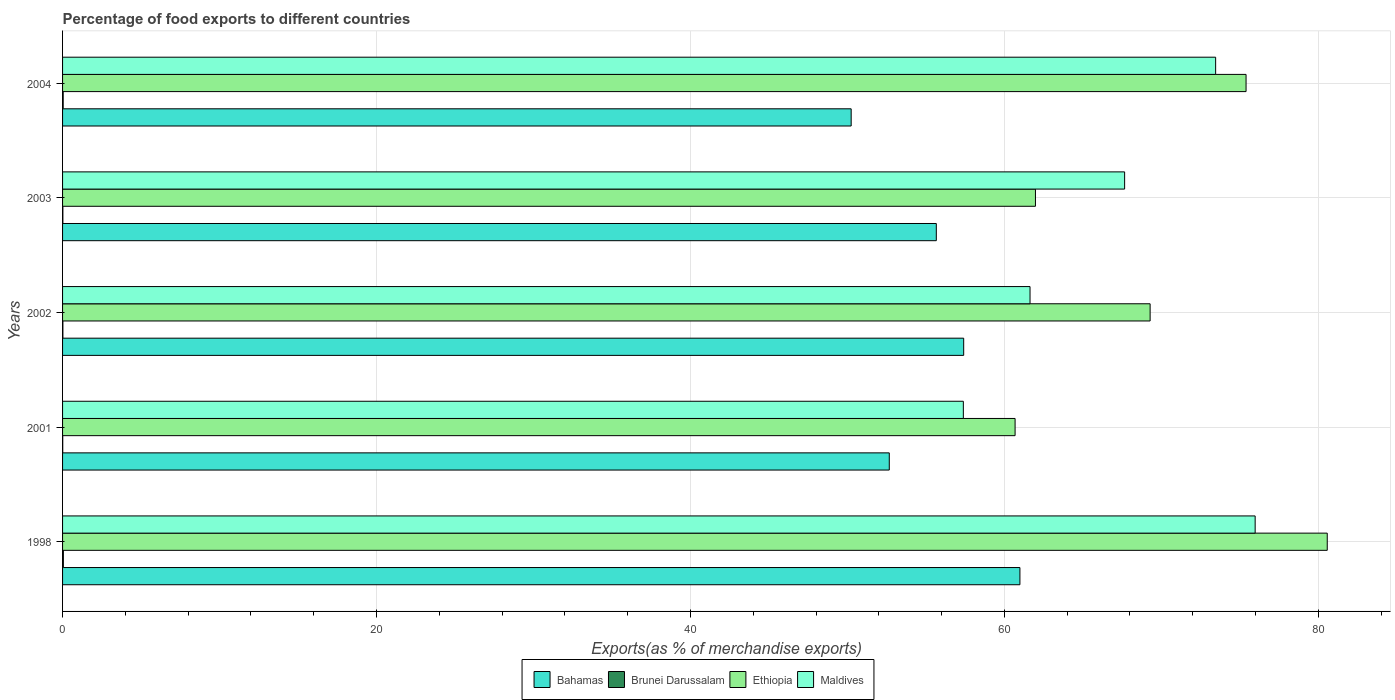How many groups of bars are there?
Make the answer very short. 5. Are the number of bars per tick equal to the number of legend labels?
Your answer should be compact. Yes. How many bars are there on the 3rd tick from the top?
Ensure brevity in your answer.  4. What is the percentage of exports to different countries in Bahamas in 2004?
Your response must be concise. 50.24. Across all years, what is the maximum percentage of exports to different countries in Maldives?
Provide a succinct answer. 75.97. Across all years, what is the minimum percentage of exports to different countries in Bahamas?
Ensure brevity in your answer.  50.24. In which year was the percentage of exports to different countries in Maldives maximum?
Give a very brief answer. 1998. In which year was the percentage of exports to different countries in Bahamas minimum?
Provide a short and direct response. 2004. What is the total percentage of exports to different countries in Bahamas in the graph?
Offer a very short reply. 276.96. What is the difference between the percentage of exports to different countries in Bahamas in 2001 and that in 2002?
Offer a very short reply. -4.74. What is the difference between the percentage of exports to different countries in Brunei Darussalam in 2004 and the percentage of exports to different countries in Bahamas in 2001?
Provide a succinct answer. -52.63. What is the average percentage of exports to different countries in Maldives per year?
Keep it short and to the point. 67.22. In the year 1998, what is the difference between the percentage of exports to different countries in Brunei Darussalam and percentage of exports to different countries in Ethiopia?
Provide a short and direct response. -80.52. In how many years, is the percentage of exports to different countries in Ethiopia greater than 32 %?
Keep it short and to the point. 5. What is the ratio of the percentage of exports to different countries in Brunei Darussalam in 2003 to that in 2004?
Your answer should be very brief. 0.51. Is the percentage of exports to different countries in Brunei Darussalam in 2001 less than that in 2003?
Offer a terse response. Yes. What is the difference between the highest and the second highest percentage of exports to different countries in Brunei Darussalam?
Your answer should be very brief. 0.01. What is the difference between the highest and the lowest percentage of exports to different countries in Maldives?
Ensure brevity in your answer.  18.59. Is it the case that in every year, the sum of the percentage of exports to different countries in Brunei Darussalam and percentage of exports to different countries in Ethiopia is greater than the sum of percentage of exports to different countries in Maldives and percentage of exports to different countries in Bahamas?
Offer a very short reply. No. What does the 3rd bar from the top in 2001 represents?
Ensure brevity in your answer.  Brunei Darussalam. What does the 3rd bar from the bottom in 2002 represents?
Your response must be concise. Ethiopia. Is it the case that in every year, the sum of the percentage of exports to different countries in Brunei Darussalam and percentage of exports to different countries in Bahamas is greater than the percentage of exports to different countries in Maldives?
Make the answer very short. No. How many years are there in the graph?
Keep it short and to the point. 5. What is the difference between two consecutive major ticks on the X-axis?
Your answer should be very brief. 20. Does the graph contain any zero values?
Your answer should be very brief. No. Does the graph contain grids?
Offer a terse response. Yes. How many legend labels are there?
Make the answer very short. 4. What is the title of the graph?
Provide a succinct answer. Percentage of food exports to different countries. What is the label or title of the X-axis?
Your response must be concise. Exports(as % of merchandise exports). What is the label or title of the Y-axis?
Ensure brevity in your answer.  Years. What is the Exports(as % of merchandise exports) of Bahamas in 1998?
Your answer should be compact. 60.99. What is the Exports(as % of merchandise exports) of Brunei Darussalam in 1998?
Offer a very short reply. 0.05. What is the Exports(as % of merchandise exports) of Ethiopia in 1998?
Your response must be concise. 80.57. What is the Exports(as % of merchandise exports) of Maldives in 1998?
Give a very brief answer. 75.97. What is the Exports(as % of merchandise exports) in Bahamas in 2001?
Your response must be concise. 52.67. What is the Exports(as % of merchandise exports) in Brunei Darussalam in 2001?
Your answer should be compact. 0.01. What is the Exports(as % of merchandise exports) of Ethiopia in 2001?
Ensure brevity in your answer.  60.68. What is the Exports(as % of merchandise exports) of Maldives in 2001?
Provide a succinct answer. 57.38. What is the Exports(as % of merchandise exports) in Bahamas in 2002?
Your answer should be very brief. 57.41. What is the Exports(as % of merchandise exports) of Brunei Darussalam in 2002?
Offer a terse response. 0.02. What is the Exports(as % of merchandise exports) in Ethiopia in 2002?
Your response must be concise. 69.28. What is the Exports(as % of merchandise exports) of Maldives in 2002?
Keep it short and to the point. 61.63. What is the Exports(as % of merchandise exports) of Bahamas in 2003?
Give a very brief answer. 55.66. What is the Exports(as % of merchandise exports) in Brunei Darussalam in 2003?
Offer a very short reply. 0.02. What is the Exports(as % of merchandise exports) in Ethiopia in 2003?
Make the answer very short. 61.98. What is the Exports(as % of merchandise exports) in Maldives in 2003?
Provide a succinct answer. 67.66. What is the Exports(as % of merchandise exports) in Bahamas in 2004?
Keep it short and to the point. 50.24. What is the Exports(as % of merchandise exports) in Brunei Darussalam in 2004?
Make the answer very short. 0.04. What is the Exports(as % of merchandise exports) in Ethiopia in 2004?
Provide a succinct answer. 75.39. What is the Exports(as % of merchandise exports) in Maldives in 2004?
Keep it short and to the point. 73.46. Across all years, what is the maximum Exports(as % of merchandise exports) of Bahamas?
Offer a very short reply. 60.99. Across all years, what is the maximum Exports(as % of merchandise exports) in Brunei Darussalam?
Offer a terse response. 0.05. Across all years, what is the maximum Exports(as % of merchandise exports) in Ethiopia?
Offer a very short reply. 80.57. Across all years, what is the maximum Exports(as % of merchandise exports) of Maldives?
Your answer should be very brief. 75.97. Across all years, what is the minimum Exports(as % of merchandise exports) in Bahamas?
Your response must be concise. 50.24. Across all years, what is the minimum Exports(as % of merchandise exports) in Brunei Darussalam?
Make the answer very short. 0.01. Across all years, what is the minimum Exports(as % of merchandise exports) in Ethiopia?
Ensure brevity in your answer.  60.68. Across all years, what is the minimum Exports(as % of merchandise exports) in Maldives?
Offer a very short reply. 57.38. What is the total Exports(as % of merchandise exports) of Bahamas in the graph?
Give a very brief answer. 276.96. What is the total Exports(as % of merchandise exports) of Brunei Darussalam in the graph?
Give a very brief answer. 0.14. What is the total Exports(as % of merchandise exports) of Ethiopia in the graph?
Your response must be concise. 347.9. What is the total Exports(as % of merchandise exports) of Maldives in the graph?
Ensure brevity in your answer.  336.1. What is the difference between the Exports(as % of merchandise exports) of Bahamas in 1998 and that in 2001?
Your answer should be very brief. 8.32. What is the difference between the Exports(as % of merchandise exports) in Brunei Darussalam in 1998 and that in 2001?
Keep it short and to the point. 0.04. What is the difference between the Exports(as % of merchandise exports) in Ethiopia in 1998 and that in 2001?
Provide a succinct answer. 19.89. What is the difference between the Exports(as % of merchandise exports) in Maldives in 1998 and that in 2001?
Offer a terse response. 18.59. What is the difference between the Exports(as % of merchandise exports) of Bahamas in 1998 and that in 2002?
Offer a terse response. 3.58. What is the difference between the Exports(as % of merchandise exports) in Brunei Darussalam in 1998 and that in 2002?
Your answer should be very brief. 0.03. What is the difference between the Exports(as % of merchandise exports) in Ethiopia in 1998 and that in 2002?
Provide a succinct answer. 11.28. What is the difference between the Exports(as % of merchandise exports) of Maldives in 1998 and that in 2002?
Your response must be concise. 14.34. What is the difference between the Exports(as % of merchandise exports) in Bahamas in 1998 and that in 2003?
Your response must be concise. 5.33. What is the difference between the Exports(as % of merchandise exports) in Brunei Darussalam in 1998 and that in 2003?
Ensure brevity in your answer.  0.03. What is the difference between the Exports(as % of merchandise exports) of Ethiopia in 1998 and that in 2003?
Offer a terse response. 18.59. What is the difference between the Exports(as % of merchandise exports) in Maldives in 1998 and that in 2003?
Give a very brief answer. 8.32. What is the difference between the Exports(as % of merchandise exports) in Bahamas in 1998 and that in 2004?
Offer a very short reply. 10.75. What is the difference between the Exports(as % of merchandise exports) in Brunei Darussalam in 1998 and that in 2004?
Give a very brief answer. 0.01. What is the difference between the Exports(as % of merchandise exports) of Ethiopia in 1998 and that in 2004?
Provide a succinct answer. 5.17. What is the difference between the Exports(as % of merchandise exports) in Maldives in 1998 and that in 2004?
Offer a very short reply. 2.52. What is the difference between the Exports(as % of merchandise exports) in Bahamas in 2001 and that in 2002?
Give a very brief answer. -4.74. What is the difference between the Exports(as % of merchandise exports) of Brunei Darussalam in 2001 and that in 2002?
Make the answer very short. -0.01. What is the difference between the Exports(as % of merchandise exports) in Ethiopia in 2001 and that in 2002?
Your answer should be very brief. -8.6. What is the difference between the Exports(as % of merchandise exports) in Maldives in 2001 and that in 2002?
Provide a succinct answer. -4.25. What is the difference between the Exports(as % of merchandise exports) of Bahamas in 2001 and that in 2003?
Make the answer very short. -3. What is the difference between the Exports(as % of merchandise exports) in Brunei Darussalam in 2001 and that in 2003?
Your response must be concise. -0.01. What is the difference between the Exports(as % of merchandise exports) of Ethiopia in 2001 and that in 2003?
Provide a succinct answer. -1.3. What is the difference between the Exports(as % of merchandise exports) in Maldives in 2001 and that in 2003?
Offer a terse response. -10.27. What is the difference between the Exports(as % of merchandise exports) of Bahamas in 2001 and that in 2004?
Your answer should be compact. 2.43. What is the difference between the Exports(as % of merchandise exports) in Brunei Darussalam in 2001 and that in 2004?
Your answer should be compact. -0.03. What is the difference between the Exports(as % of merchandise exports) in Ethiopia in 2001 and that in 2004?
Offer a terse response. -14.71. What is the difference between the Exports(as % of merchandise exports) in Maldives in 2001 and that in 2004?
Give a very brief answer. -16.07. What is the difference between the Exports(as % of merchandise exports) in Bahamas in 2002 and that in 2003?
Give a very brief answer. 1.74. What is the difference between the Exports(as % of merchandise exports) in Brunei Darussalam in 2002 and that in 2003?
Ensure brevity in your answer.  0. What is the difference between the Exports(as % of merchandise exports) in Ethiopia in 2002 and that in 2003?
Keep it short and to the point. 7.31. What is the difference between the Exports(as % of merchandise exports) of Maldives in 2002 and that in 2003?
Provide a succinct answer. -6.03. What is the difference between the Exports(as % of merchandise exports) in Bahamas in 2002 and that in 2004?
Provide a succinct answer. 7.17. What is the difference between the Exports(as % of merchandise exports) in Brunei Darussalam in 2002 and that in 2004?
Give a very brief answer. -0.02. What is the difference between the Exports(as % of merchandise exports) in Ethiopia in 2002 and that in 2004?
Keep it short and to the point. -6.11. What is the difference between the Exports(as % of merchandise exports) in Maldives in 2002 and that in 2004?
Offer a very short reply. -11.82. What is the difference between the Exports(as % of merchandise exports) in Bahamas in 2003 and that in 2004?
Your answer should be very brief. 5.42. What is the difference between the Exports(as % of merchandise exports) in Brunei Darussalam in 2003 and that in 2004?
Your answer should be compact. -0.02. What is the difference between the Exports(as % of merchandise exports) in Ethiopia in 2003 and that in 2004?
Make the answer very short. -13.42. What is the difference between the Exports(as % of merchandise exports) of Maldives in 2003 and that in 2004?
Ensure brevity in your answer.  -5.8. What is the difference between the Exports(as % of merchandise exports) of Bahamas in 1998 and the Exports(as % of merchandise exports) of Brunei Darussalam in 2001?
Your answer should be very brief. 60.98. What is the difference between the Exports(as % of merchandise exports) in Bahamas in 1998 and the Exports(as % of merchandise exports) in Ethiopia in 2001?
Your response must be concise. 0.31. What is the difference between the Exports(as % of merchandise exports) in Bahamas in 1998 and the Exports(as % of merchandise exports) in Maldives in 2001?
Keep it short and to the point. 3.6. What is the difference between the Exports(as % of merchandise exports) of Brunei Darussalam in 1998 and the Exports(as % of merchandise exports) of Ethiopia in 2001?
Keep it short and to the point. -60.63. What is the difference between the Exports(as % of merchandise exports) of Brunei Darussalam in 1998 and the Exports(as % of merchandise exports) of Maldives in 2001?
Your answer should be very brief. -57.33. What is the difference between the Exports(as % of merchandise exports) of Ethiopia in 1998 and the Exports(as % of merchandise exports) of Maldives in 2001?
Give a very brief answer. 23.18. What is the difference between the Exports(as % of merchandise exports) of Bahamas in 1998 and the Exports(as % of merchandise exports) of Brunei Darussalam in 2002?
Give a very brief answer. 60.97. What is the difference between the Exports(as % of merchandise exports) in Bahamas in 1998 and the Exports(as % of merchandise exports) in Ethiopia in 2002?
Give a very brief answer. -8.3. What is the difference between the Exports(as % of merchandise exports) in Bahamas in 1998 and the Exports(as % of merchandise exports) in Maldives in 2002?
Make the answer very short. -0.64. What is the difference between the Exports(as % of merchandise exports) in Brunei Darussalam in 1998 and the Exports(as % of merchandise exports) in Ethiopia in 2002?
Provide a short and direct response. -69.23. What is the difference between the Exports(as % of merchandise exports) in Brunei Darussalam in 1998 and the Exports(as % of merchandise exports) in Maldives in 2002?
Make the answer very short. -61.58. What is the difference between the Exports(as % of merchandise exports) of Ethiopia in 1998 and the Exports(as % of merchandise exports) of Maldives in 2002?
Your response must be concise. 18.93. What is the difference between the Exports(as % of merchandise exports) of Bahamas in 1998 and the Exports(as % of merchandise exports) of Brunei Darussalam in 2003?
Your answer should be very brief. 60.97. What is the difference between the Exports(as % of merchandise exports) in Bahamas in 1998 and the Exports(as % of merchandise exports) in Ethiopia in 2003?
Give a very brief answer. -0.99. What is the difference between the Exports(as % of merchandise exports) in Bahamas in 1998 and the Exports(as % of merchandise exports) in Maldives in 2003?
Provide a short and direct response. -6.67. What is the difference between the Exports(as % of merchandise exports) of Brunei Darussalam in 1998 and the Exports(as % of merchandise exports) of Ethiopia in 2003?
Your answer should be very brief. -61.93. What is the difference between the Exports(as % of merchandise exports) of Brunei Darussalam in 1998 and the Exports(as % of merchandise exports) of Maldives in 2003?
Make the answer very short. -67.61. What is the difference between the Exports(as % of merchandise exports) of Ethiopia in 1998 and the Exports(as % of merchandise exports) of Maldives in 2003?
Keep it short and to the point. 12.91. What is the difference between the Exports(as % of merchandise exports) of Bahamas in 1998 and the Exports(as % of merchandise exports) of Brunei Darussalam in 2004?
Give a very brief answer. 60.95. What is the difference between the Exports(as % of merchandise exports) in Bahamas in 1998 and the Exports(as % of merchandise exports) in Ethiopia in 2004?
Provide a succinct answer. -14.41. What is the difference between the Exports(as % of merchandise exports) of Bahamas in 1998 and the Exports(as % of merchandise exports) of Maldives in 2004?
Provide a short and direct response. -12.47. What is the difference between the Exports(as % of merchandise exports) of Brunei Darussalam in 1998 and the Exports(as % of merchandise exports) of Ethiopia in 2004?
Keep it short and to the point. -75.34. What is the difference between the Exports(as % of merchandise exports) of Brunei Darussalam in 1998 and the Exports(as % of merchandise exports) of Maldives in 2004?
Your response must be concise. -73.4. What is the difference between the Exports(as % of merchandise exports) in Ethiopia in 1998 and the Exports(as % of merchandise exports) in Maldives in 2004?
Offer a very short reply. 7.11. What is the difference between the Exports(as % of merchandise exports) of Bahamas in 2001 and the Exports(as % of merchandise exports) of Brunei Darussalam in 2002?
Give a very brief answer. 52.65. What is the difference between the Exports(as % of merchandise exports) in Bahamas in 2001 and the Exports(as % of merchandise exports) in Ethiopia in 2002?
Provide a short and direct response. -16.62. What is the difference between the Exports(as % of merchandise exports) of Bahamas in 2001 and the Exports(as % of merchandise exports) of Maldives in 2002?
Make the answer very short. -8.97. What is the difference between the Exports(as % of merchandise exports) of Brunei Darussalam in 2001 and the Exports(as % of merchandise exports) of Ethiopia in 2002?
Give a very brief answer. -69.27. What is the difference between the Exports(as % of merchandise exports) of Brunei Darussalam in 2001 and the Exports(as % of merchandise exports) of Maldives in 2002?
Make the answer very short. -61.62. What is the difference between the Exports(as % of merchandise exports) of Ethiopia in 2001 and the Exports(as % of merchandise exports) of Maldives in 2002?
Offer a terse response. -0.95. What is the difference between the Exports(as % of merchandise exports) in Bahamas in 2001 and the Exports(as % of merchandise exports) in Brunei Darussalam in 2003?
Offer a very short reply. 52.65. What is the difference between the Exports(as % of merchandise exports) of Bahamas in 2001 and the Exports(as % of merchandise exports) of Ethiopia in 2003?
Offer a very short reply. -9.31. What is the difference between the Exports(as % of merchandise exports) of Bahamas in 2001 and the Exports(as % of merchandise exports) of Maldives in 2003?
Provide a short and direct response. -14.99. What is the difference between the Exports(as % of merchandise exports) in Brunei Darussalam in 2001 and the Exports(as % of merchandise exports) in Ethiopia in 2003?
Your answer should be compact. -61.97. What is the difference between the Exports(as % of merchandise exports) of Brunei Darussalam in 2001 and the Exports(as % of merchandise exports) of Maldives in 2003?
Your response must be concise. -67.65. What is the difference between the Exports(as % of merchandise exports) of Ethiopia in 2001 and the Exports(as % of merchandise exports) of Maldives in 2003?
Ensure brevity in your answer.  -6.98. What is the difference between the Exports(as % of merchandise exports) in Bahamas in 2001 and the Exports(as % of merchandise exports) in Brunei Darussalam in 2004?
Keep it short and to the point. 52.63. What is the difference between the Exports(as % of merchandise exports) in Bahamas in 2001 and the Exports(as % of merchandise exports) in Ethiopia in 2004?
Your answer should be compact. -22.73. What is the difference between the Exports(as % of merchandise exports) in Bahamas in 2001 and the Exports(as % of merchandise exports) in Maldives in 2004?
Give a very brief answer. -20.79. What is the difference between the Exports(as % of merchandise exports) of Brunei Darussalam in 2001 and the Exports(as % of merchandise exports) of Ethiopia in 2004?
Keep it short and to the point. -75.38. What is the difference between the Exports(as % of merchandise exports) in Brunei Darussalam in 2001 and the Exports(as % of merchandise exports) in Maldives in 2004?
Give a very brief answer. -73.45. What is the difference between the Exports(as % of merchandise exports) in Ethiopia in 2001 and the Exports(as % of merchandise exports) in Maldives in 2004?
Offer a terse response. -12.78. What is the difference between the Exports(as % of merchandise exports) in Bahamas in 2002 and the Exports(as % of merchandise exports) in Brunei Darussalam in 2003?
Offer a terse response. 57.39. What is the difference between the Exports(as % of merchandise exports) of Bahamas in 2002 and the Exports(as % of merchandise exports) of Ethiopia in 2003?
Ensure brevity in your answer.  -4.57. What is the difference between the Exports(as % of merchandise exports) in Bahamas in 2002 and the Exports(as % of merchandise exports) in Maldives in 2003?
Provide a short and direct response. -10.25. What is the difference between the Exports(as % of merchandise exports) in Brunei Darussalam in 2002 and the Exports(as % of merchandise exports) in Ethiopia in 2003?
Keep it short and to the point. -61.96. What is the difference between the Exports(as % of merchandise exports) in Brunei Darussalam in 2002 and the Exports(as % of merchandise exports) in Maldives in 2003?
Your response must be concise. -67.64. What is the difference between the Exports(as % of merchandise exports) of Ethiopia in 2002 and the Exports(as % of merchandise exports) of Maldives in 2003?
Your answer should be compact. 1.63. What is the difference between the Exports(as % of merchandise exports) in Bahamas in 2002 and the Exports(as % of merchandise exports) in Brunei Darussalam in 2004?
Provide a short and direct response. 57.37. What is the difference between the Exports(as % of merchandise exports) in Bahamas in 2002 and the Exports(as % of merchandise exports) in Ethiopia in 2004?
Give a very brief answer. -17.99. What is the difference between the Exports(as % of merchandise exports) in Bahamas in 2002 and the Exports(as % of merchandise exports) in Maldives in 2004?
Your response must be concise. -16.05. What is the difference between the Exports(as % of merchandise exports) of Brunei Darussalam in 2002 and the Exports(as % of merchandise exports) of Ethiopia in 2004?
Offer a terse response. -75.37. What is the difference between the Exports(as % of merchandise exports) in Brunei Darussalam in 2002 and the Exports(as % of merchandise exports) in Maldives in 2004?
Provide a succinct answer. -73.44. What is the difference between the Exports(as % of merchandise exports) in Ethiopia in 2002 and the Exports(as % of merchandise exports) in Maldives in 2004?
Your answer should be very brief. -4.17. What is the difference between the Exports(as % of merchandise exports) of Bahamas in 2003 and the Exports(as % of merchandise exports) of Brunei Darussalam in 2004?
Offer a very short reply. 55.62. What is the difference between the Exports(as % of merchandise exports) of Bahamas in 2003 and the Exports(as % of merchandise exports) of Ethiopia in 2004?
Your answer should be very brief. -19.73. What is the difference between the Exports(as % of merchandise exports) in Bahamas in 2003 and the Exports(as % of merchandise exports) in Maldives in 2004?
Make the answer very short. -17.79. What is the difference between the Exports(as % of merchandise exports) of Brunei Darussalam in 2003 and the Exports(as % of merchandise exports) of Ethiopia in 2004?
Your answer should be compact. -75.37. What is the difference between the Exports(as % of merchandise exports) in Brunei Darussalam in 2003 and the Exports(as % of merchandise exports) in Maldives in 2004?
Your response must be concise. -73.44. What is the difference between the Exports(as % of merchandise exports) in Ethiopia in 2003 and the Exports(as % of merchandise exports) in Maldives in 2004?
Keep it short and to the point. -11.48. What is the average Exports(as % of merchandise exports) in Bahamas per year?
Offer a very short reply. 55.39. What is the average Exports(as % of merchandise exports) of Brunei Darussalam per year?
Offer a terse response. 0.03. What is the average Exports(as % of merchandise exports) in Ethiopia per year?
Offer a terse response. 69.58. What is the average Exports(as % of merchandise exports) of Maldives per year?
Offer a very short reply. 67.22. In the year 1998, what is the difference between the Exports(as % of merchandise exports) of Bahamas and Exports(as % of merchandise exports) of Brunei Darussalam?
Offer a very short reply. 60.94. In the year 1998, what is the difference between the Exports(as % of merchandise exports) of Bahamas and Exports(as % of merchandise exports) of Ethiopia?
Keep it short and to the point. -19.58. In the year 1998, what is the difference between the Exports(as % of merchandise exports) of Bahamas and Exports(as % of merchandise exports) of Maldives?
Ensure brevity in your answer.  -14.99. In the year 1998, what is the difference between the Exports(as % of merchandise exports) of Brunei Darussalam and Exports(as % of merchandise exports) of Ethiopia?
Ensure brevity in your answer.  -80.52. In the year 1998, what is the difference between the Exports(as % of merchandise exports) of Brunei Darussalam and Exports(as % of merchandise exports) of Maldives?
Keep it short and to the point. -75.92. In the year 1998, what is the difference between the Exports(as % of merchandise exports) in Ethiopia and Exports(as % of merchandise exports) in Maldives?
Your answer should be very brief. 4.59. In the year 2001, what is the difference between the Exports(as % of merchandise exports) of Bahamas and Exports(as % of merchandise exports) of Brunei Darussalam?
Your answer should be very brief. 52.66. In the year 2001, what is the difference between the Exports(as % of merchandise exports) of Bahamas and Exports(as % of merchandise exports) of Ethiopia?
Ensure brevity in your answer.  -8.01. In the year 2001, what is the difference between the Exports(as % of merchandise exports) of Bahamas and Exports(as % of merchandise exports) of Maldives?
Ensure brevity in your answer.  -4.72. In the year 2001, what is the difference between the Exports(as % of merchandise exports) in Brunei Darussalam and Exports(as % of merchandise exports) in Ethiopia?
Your answer should be very brief. -60.67. In the year 2001, what is the difference between the Exports(as % of merchandise exports) in Brunei Darussalam and Exports(as % of merchandise exports) in Maldives?
Provide a short and direct response. -57.37. In the year 2001, what is the difference between the Exports(as % of merchandise exports) in Ethiopia and Exports(as % of merchandise exports) in Maldives?
Your answer should be compact. 3.3. In the year 2002, what is the difference between the Exports(as % of merchandise exports) of Bahamas and Exports(as % of merchandise exports) of Brunei Darussalam?
Make the answer very short. 57.39. In the year 2002, what is the difference between the Exports(as % of merchandise exports) in Bahamas and Exports(as % of merchandise exports) in Ethiopia?
Ensure brevity in your answer.  -11.88. In the year 2002, what is the difference between the Exports(as % of merchandise exports) in Bahamas and Exports(as % of merchandise exports) in Maldives?
Offer a terse response. -4.23. In the year 2002, what is the difference between the Exports(as % of merchandise exports) in Brunei Darussalam and Exports(as % of merchandise exports) in Ethiopia?
Your answer should be very brief. -69.26. In the year 2002, what is the difference between the Exports(as % of merchandise exports) in Brunei Darussalam and Exports(as % of merchandise exports) in Maldives?
Offer a terse response. -61.61. In the year 2002, what is the difference between the Exports(as % of merchandise exports) of Ethiopia and Exports(as % of merchandise exports) of Maldives?
Ensure brevity in your answer.  7.65. In the year 2003, what is the difference between the Exports(as % of merchandise exports) of Bahamas and Exports(as % of merchandise exports) of Brunei Darussalam?
Make the answer very short. 55.64. In the year 2003, what is the difference between the Exports(as % of merchandise exports) of Bahamas and Exports(as % of merchandise exports) of Ethiopia?
Keep it short and to the point. -6.32. In the year 2003, what is the difference between the Exports(as % of merchandise exports) of Bahamas and Exports(as % of merchandise exports) of Maldives?
Ensure brevity in your answer.  -12. In the year 2003, what is the difference between the Exports(as % of merchandise exports) of Brunei Darussalam and Exports(as % of merchandise exports) of Ethiopia?
Your answer should be very brief. -61.96. In the year 2003, what is the difference between the Exports(as % of merchandise exports) of Brunei Darussalam and Exports(as % of merchandise exports) of Maldives?
Keep it short and to the point. -67.64. In the year 2003, what is the difference between the Exports(as % of merchandise exports) of Ethiopia and Exports(as % of merchandise exports) of Maldives?
Provide a succinct answer. -5.68. In the year 2004, what is the difference between the Exports(as % of merchandise exports) of Bahamas and Exports(as % of merchandise exports) of Brunei Darussalam?
Offer a very short reply. 50.2. In the year 2004, what is the difference between the Exports(as % of merchandise exports) of Bahamas and Exports(as % of merchandise exports) of Ethiopia?
Provide a succinct answer. -25.16. In the year 2004, what is the difference between the Exports(as % of merchandise exports) of Bahamas and Exports(as % of merchandise exports) of Maldives?
Provide a short and direct response. -23.22. In the year 2004, what is the difference between the Exports(as % of merchandise exports) in Brunei Darussalam and Exports(as % of merchandise exports) in Ethiopia?
Your response must be concise. -75.35. In the year 2004, what is the difference between the Exports(as % of merchandise exports) in Brunei Darussalam and Exports(as % of merchandise exports) in Maldives?
Ensure brevity in your answer.  -73.42. In the year 2004, what is the difference between the Exports(as % of merchandise exports) of Ethiopia and Exports(as % of merchandise exports) of Maldives?
Your answer should be very brief. 1.94. What is the ratio of the Exports(as % of merchandise exports) of Bahamas in 1998 to that in 2001?
Make the answer very short. 1.16. What is the ratio of the Exports(as % of merchandise exports) of Brunei Darussalam in 1998 to that in 2001?
Provide a short and direct response. 4.94. What is the ratio of the Exports(as % of merchandise exports) of Ethiopia in 1998 to that in 2001?
Ensure brevity in your answer.  1.33. What is the ratio of the Exports(as % of merchandise exports) of Maldives in 1998 to that in 2001?
Offer a terse response. 1.32. What is the ratio of the Exports(as % of merchandise exports) in Bahamas in 1998 to that in 2002?
Make the answer very short. 1.06. What is the ratio of the Exports(as % of merchandise exports) of Brunei Darussalam in 1998 to that in 2002?
Make the answer very short. 2.52. What is the ratio of the Exports(as % of merchandise exports) in Ethiopia in 1998 to that in 2002?
Offer a very short reply. 1.16. What is the ratio of the Exports(as % of merchandise exports) of Maldives in 1998 to that in 2002?
Keep it short and to the point. 1.23. What is the ratio of the Exports(as % of merchandise exports) of Bahamas in 1998 to that in 2003?
Your response must be concise. 1.1. What is the ratio of the Exports(as % of merchandise exports) in Brunei Darussalam in 1998 to that in 2003?
Provide a succinct answer. 2.54. What is the ratio of the Exports(as % of merchandise exports) of Ethiopia in 1998 to that in 2003?
Offer a very short reply. 1.3. What is the ratio of the Exports(as % of merchandise exports) in Maldives in 1998 to that in 2003?
Your answer should be very brief. 1.12. What is the ratio of the Exports(as % of merchandise exports) in Bahamas in 1998 to that in 2004?
Provide a succinct answer. 1.21. What is the ratio of the Exports(as % of merchandise exports) of Brunei Darussalam in 1998 to that in 2004?
Ensure brevity in your answer.  1.31. What is the ratio of the Exports(as % of merchandise exports) of Ethiopia in 1998 to that in 2004?
Give a very brief answer. 1.07. What is the ratio of the Exports(as % of merchandise exports) of Maldives in 1998 to that in 2004?
Give a very brief answer. 1.03. What is the ratio of the Exports(as % of merchandise exports) in Bahamas in 2001 to that in 2002?
Provide a short and direct response. 0.92. What is the ratio of the Exports(as % of merchandise exports) of Brunei Darussalam in 2001 to that in 2002?
Provide a short and direct response. 0.51. What is the ratio of the Exports(as % of merchandise exports) of Ethiopia in 2001 to that in 2002?
Offer a very short reply. 0.88. What is the ratio of the Exports(as % of merchandise exports) in Maldives in 2001 to that in 2002?
Ensure brevity in your answer.  0.93. What is the ratio of the Exports(as % of merchandise exports) in Bahamas in 2001 to that in 2003?
Provide a short and direct response. 0.95. What is the ratio of the Exports(as % of merchandise exports) in Brunei Darussalam in 2001 to that in 2003?
Offer a terse response. 0.51. What is the ratio of the Exports(as % of merchandise exports) in Ethiopia in 2001 to that in 2003?
Ensure brevity in your answer.  0.98. What is the ratio of the Exports(as % of merchandise exports) of Maldives in 2001 to that in 2003?
Your answer should be compact. 0.85. What is the ratio of the Exports(as % of merchandise exports) in Bahamas in 2001 to that in 2004?
Your response must be concise. 1.05. What is the ratio of the Exports(as % of merchandise exports) in Brunei Darussalam in 2001 to that in 2004?
Provide a succinct answer. 0.26. What is the ratio of the Exports(as % of merchandise exports) of Ethiopia in 2001 to that in 2004?
Keep it short and to the point. 0.8. What is the ratio of the Exports(as % of merchandise exports) in Maldives in 2001 to that in 2004?
Offer a very short reply. 0.78. What is the ratio of the Exports(as % of merchandise exports) in Bahamas in 2002 to that in 2003?
Keep it short and to the point. 1.03. What is the ratio of the Exports(as % of merchandise exports) of Brunei Darussalam in 2002 to that in 2003?
Your answer should be compact. 1.01. What is the ratio of the Exports(as % of merchandise exports) of Ethiopia in 2002 to that in 2003?
Keep it short and to the point. 1.12. What is the ratio of the Exports(as % of merchandise exports) in Maldives in 2002 to that in 2003?
Give a very brief answer. 0.91. What is the ratio of the Exports(as % of merchandise exports) in Bahamas in 2002 to that in 2004?
Provide a succinct answer. 1.14. What is the ratio of the Exports(as % of merchandise exports) in Brunei Darussalam in 2002 to that in 2004?
Provide a short and direct response. 0.52. What is the ratio of the Exports(as % of merchandise exports) of Ethiopia in 2002 to that in 2004?
Ensure brevity in your answer.  0.92. What is the ratio of the Exports(as % of merchandise exports) in Maldives in 2002 to that in 2004?
Make the answer very short. 0.84. What is the ratio of the Exports(as % of merchandise exports) in Bahamas in 2003 to that in 2004?
Offer a very short reply. 1.11. What is the ratio of the Exports(as % of merchandise exports) in Brunei Darussalam in 2003 to that in 2004?
Provide a succinct answer. 0.51. What is the ratio of the Exports(as % of merchandise exports) in Ethiopia in 2003 to that in 2004?
Provide a short and direct response. 0.82. What is the ratio of the Exports(as % of merchandise exports) of Maldives in 2003 to that in 2004?
Offer a very short reply. 0.92. What is the difference between the highest and the second highest Exports(as % of merchandise exports) in Bahamas?
Give a very brief answer. 3.58. What is the difference between the highest and the second highest Exports(as % of merchandise exports) in Brunei Darussalam?
Keep it short and to the point. 0.01. What is the difference between the highest and the second highest Exports(as % of merchandise exports) of Ethiopia?
Offer a very short reply. 5.17. What is the difference between the highest and the second highest Exports(as % of merchandise exports) of Maldives?
Provide a succinct answer. 2.52. What is the difference between the highest and the lowest Exports(as % of merchandise exports) of Bahamas?
Your answer should be compact. 10.75. What is the difference between the highest and the lowest Exports(as % of merchandise exports) of Brunei Darussalam?
Make the answer very short. 0.04. What is the difference between the highest and the lowest Exports(as % of merchandise exports) of Ethiopia?
Provide a succinct answer. 19.89. What is the difference between the highest and the lowest Exports(as % of merchandise exports) of Maldives?
Offer a very short reply. 18.59. 